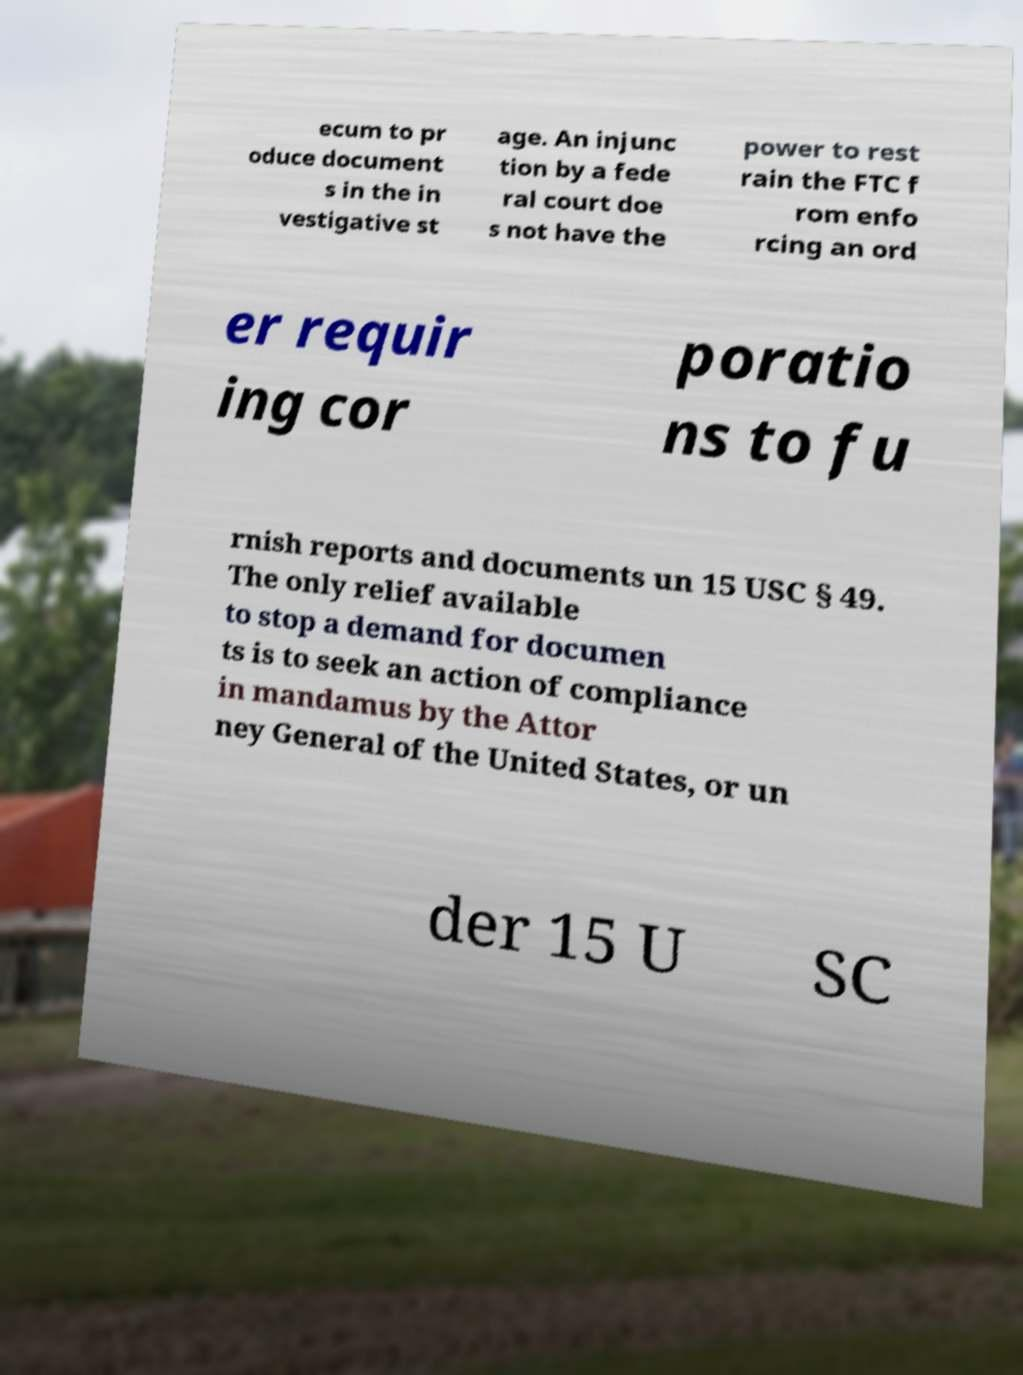Could you extract and type out the text from this image? ecum to pr oduce document s in the in vestigative st age. An injunc tion by a fede ral court doe s not have the power to rest rain the FTC f rom enfo rcing an ord er requir ing cor poratio ns to fu rnish reports and documents un 15 USC § 49. The only relief available to stop a demand for documen ts is to seek an action of compliance in mandamus by the Attor ney General of the United States, or un der 15 U SC 